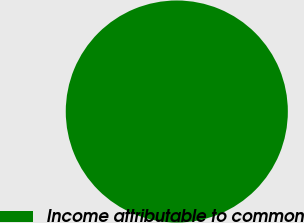<chart> <loc_0><loc_0><loc_500><loc_500><pie_chart><fcel>Income attributable to common<nl><fcel>100.0%<nl></chart> 